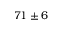Convert formula to latex. <formula><loc_0><loc_0><loc_500><loc_500>7 1 \pm 6</formula> 